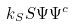<formula> <loc_0><loc_0><loc_500><loc_500>k _ { S } S \Psi \Psi ^ { c }</formula> 